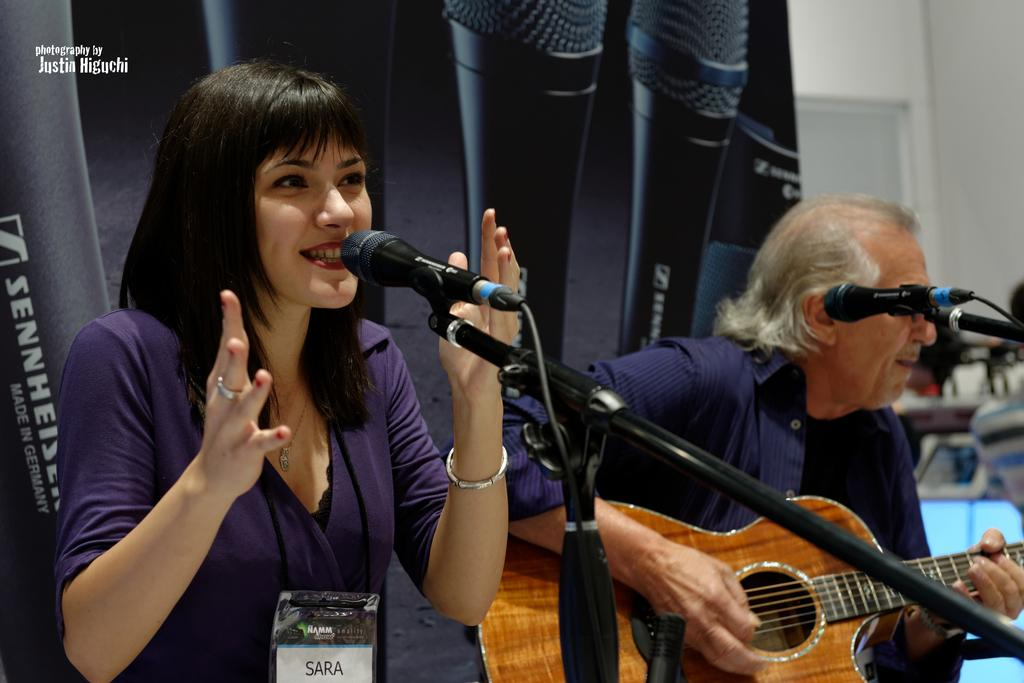Who is the main subject in the image? There is a woman in the image. What is the woman doing in the image? The woman is smiling and standing in front of a mic. Are there any other people in the image? Yes, there is a man in the image. What is the man holding in the image? The man is holding a guitar. What type of plantation can be seen in the background of the image? There is no plantation visible in the image; it features a woman in front of a mic and a man holding a guitar. 